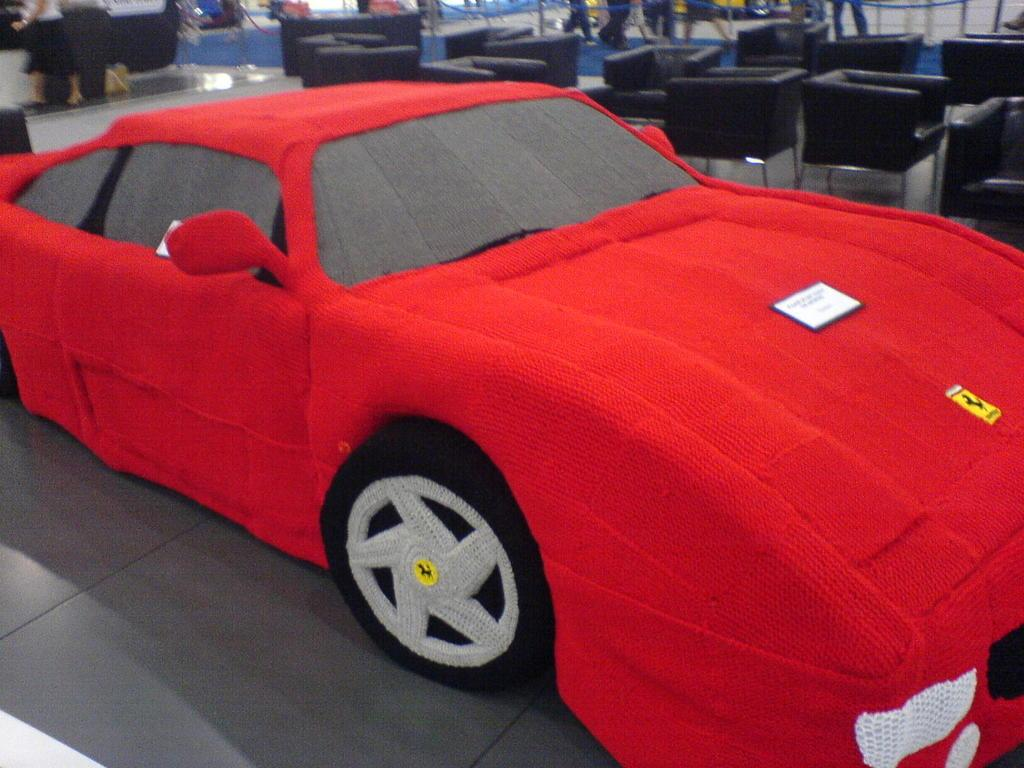What is the main subject of the image? The main subject of the image is a car made with an item on a platform. What can be seen in the background of the image? In the background, there are chairs, people standing and walking, a floor, and other objects. Can you describe the people in the background? The people in the background are standing and walking. What type of humor can be seen in the image? There is no humor present in the image; it features a car made with an item on a platform and people in the background. Can you tell me how many rats are visible in the image? There are no rats present in the image. 